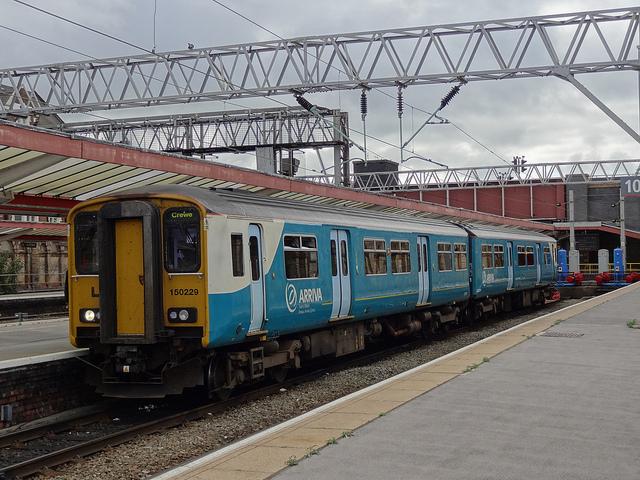What color is the train?
Write a very short answer. Blue. Which direction is this train going?
Short answer required. North. Is this a passenger train?
Give a very brief answer. Yes. How many sets of tracks?
Short answer required. 2. Is the train crowded?
Be succinct. No. Is this a new train?
Write a very short answer. No. 